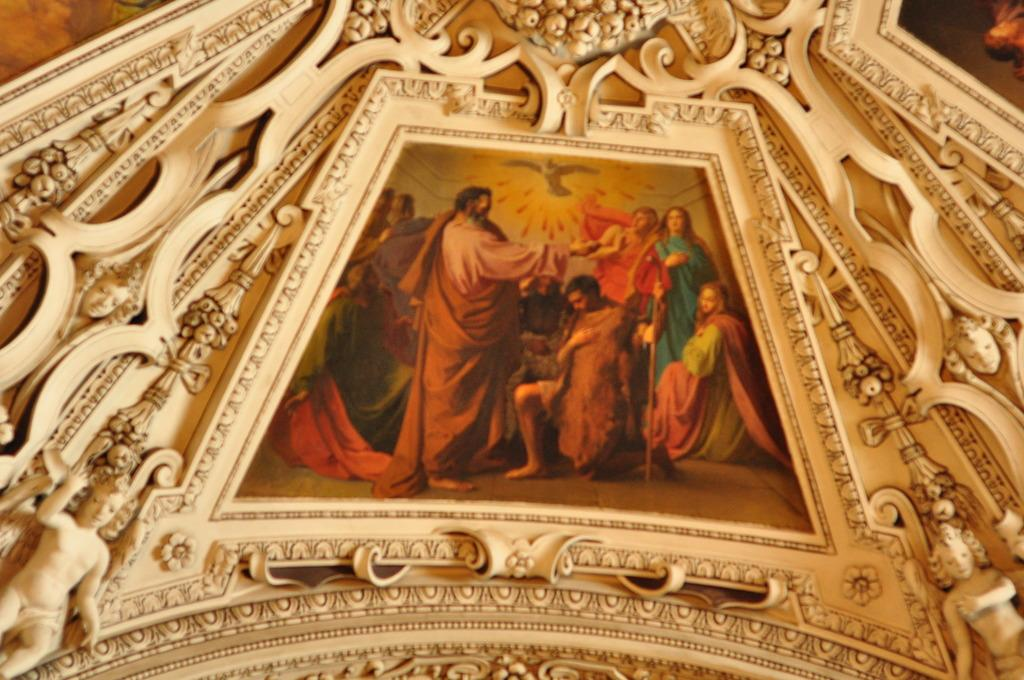What object is present in the image that typically holds a photograph? There is a photo frame in the image. Who or what can be seen in the photo frame? There are people in the photo frame. What type of artwork is visible in the image? There are sculptures in the image. How many nails are used to hold the bag in the image? There is no bag or nails present in the image. Is there a stream visible in the image? There is no stream present in the image. 